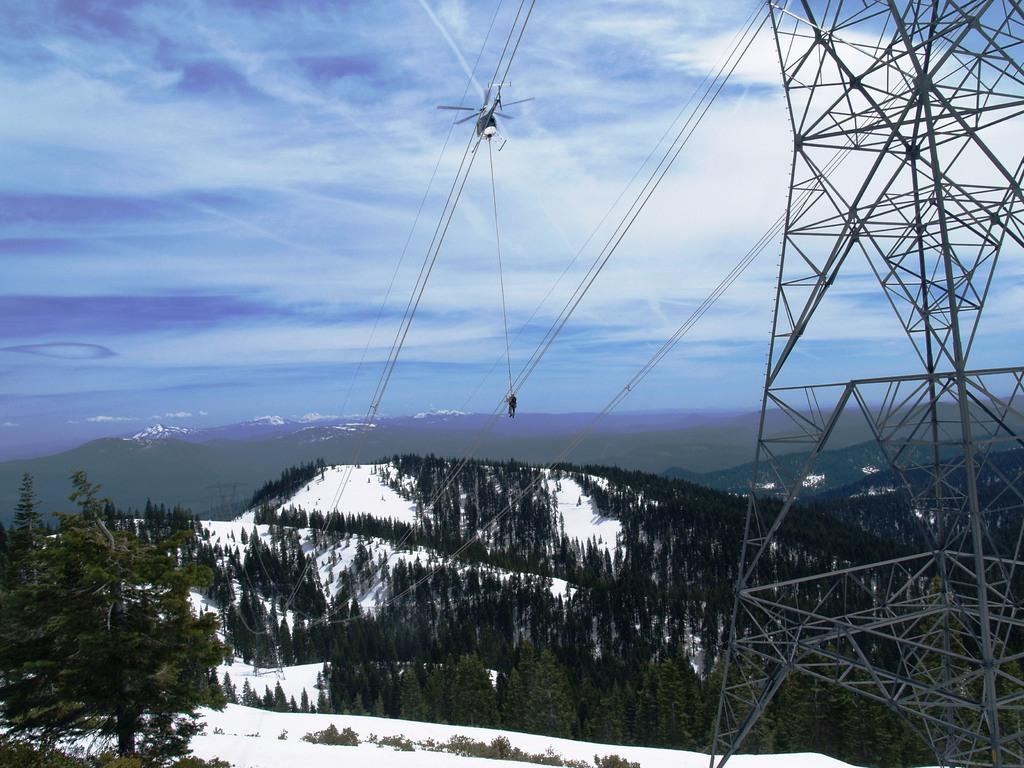What is the main structure in the image? There is a tower in the image. What else can be seen in the image besides the tower? There are wires, trees, an airplane, snow, a person, hills, and sky with clouds visible in the image. How many types of natural elements are present in the image? There are three types of natural elements present in the image: trees, snow, and hills. What is the weather like in the image? The presence of snow suggests that the weather is cold. What type of quince is being used as a decoration in the image? There is no quince present in the image. Can you tell me how many actors are visible in the image? There are no actors present in the image. 